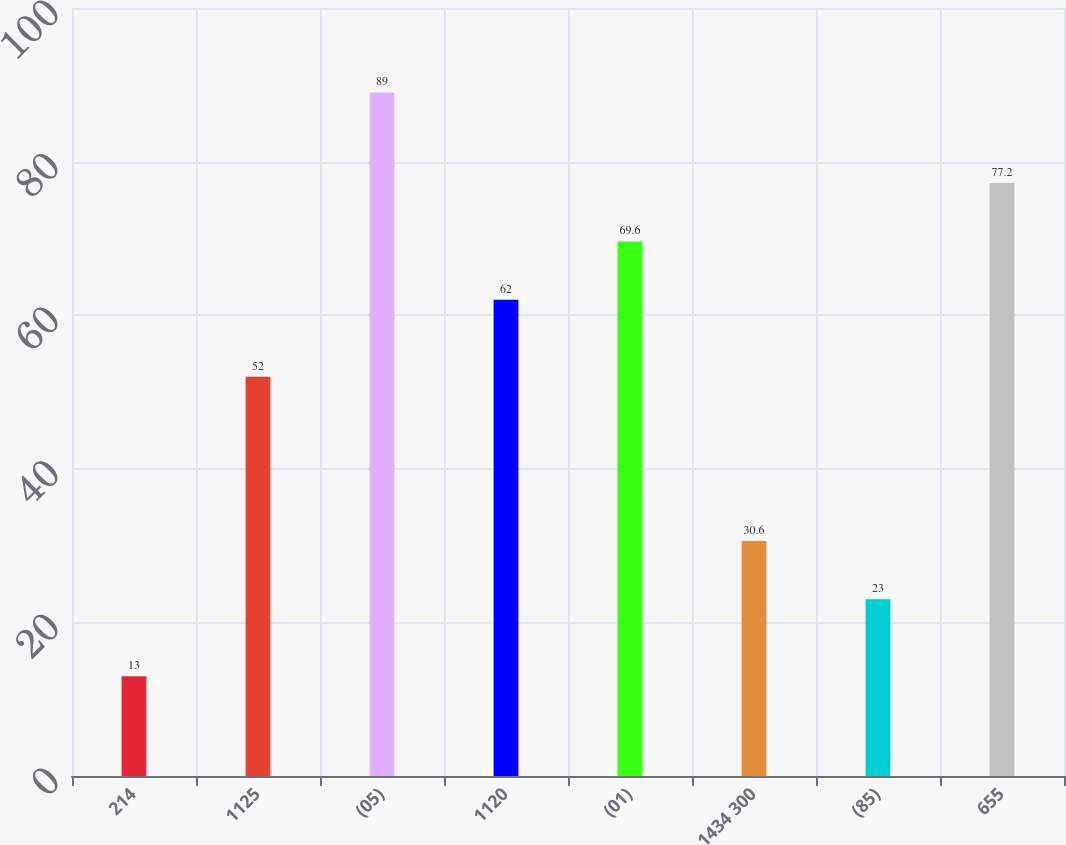Convert chart. <chart><loc_0><loc_0><loc_500><loc_500><bar_chart><fcel>214<fcel>1125<fcel>(05)<fcel>1120<fcel>(01)<fcel>1434 300<fcel>(85)<fcel>655<nl><fcel>13<fcel>52<fcel>89<fcel>62<fcel>69.6<fcel>30.6<fcel>23<fcel>77.2<nl></chart> 